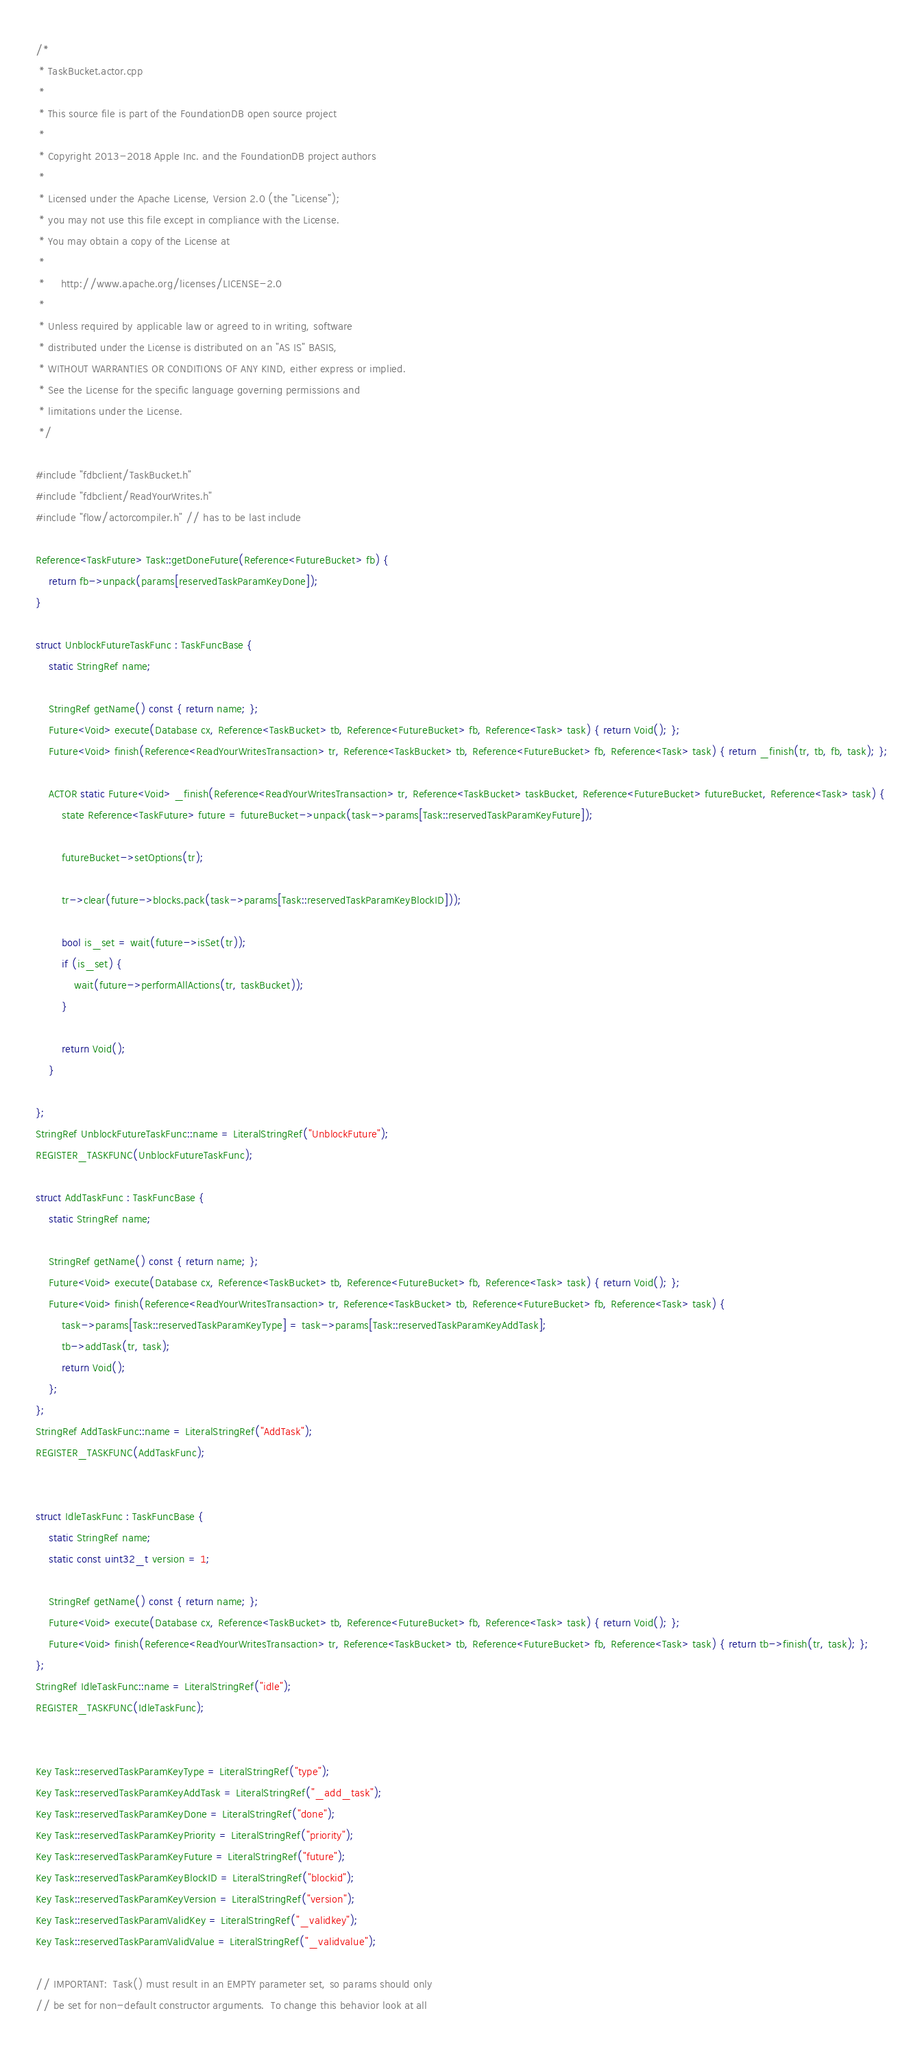<code> <loc_0><loc_0><loc_500><loc_500><_C++_>/*
 * TaskBucket.actor.cpp
 *
 * This source file is part of the FoundationDB open source project
 *
 * Copyright 2013-2018 Apple Inc. and the FoundationDB project authors
 *
 * Licensed under the Apache License, Version 2.0 (the "License");
 * you may not use this file except in compliance with the License.
 * You may obtain a copy of the License at
 *
 *     http://www.apache.org/licenses/LICENSE-2.0
 *
 * Unless required by applicable law or agreed to in writing, software
 * distributed under the License is distributed on an "AS IS" BASIS,
 * WITHOUT WARRANTIES OR CONDITIONS OF ANY KIND, either express or implied.
 * See the License for the specific language governing permissions and
 * limitations under the License.
 */

#include "fdbclient/TaskBucket.h"
#include "fdbclient/ReadYourWrites.h"
#include "flow/actorcompiler.h" // has to be last include

Reference<TaskFuture> Task::getDoneFuture(Reference<FutureBucket> fb) {
	return fb->unpack(params[reservedTaskParamKeyDone]);
}

struct UnblockFutureTaskFunc : TaskFuncBase {
	static StringRef name;

	StringRef getName() const { return name; };
	Future<Void> execute(Database cx, Reference<TaskBucket> tb, Reference<FutureBucket> fb, Reference<Task> task) { return Void(); };
	Future<Void> finish(Reference<ReadYourWritesTransaction> tr, Reference<TaskBucket> tb, Reference<FutureBucket> fb, Reference<Task> task) { return _finish(tr, tb, fb, task); };

	ACTOR static Future<Void> _finish(Reference<ReadYourWritesTransaction> tr, Reference<TaskBucket> taskBucket, Reference<FutureBucket> futureBucket, Reference<Task> task) {
		state Reference<TaskFuture> future = futureBucket->unpack(task->params[Task::reservedTaskParamKeyFuture]);

		futureBucket->setOptions(tr);

		tr->clear(future->blocks.pack(task->params[Task::reservedTaskParamKeyBlockID]));

		bool is_set = wait(future->isSet(tr));
		if (is_set) {
			wait(future->performAllActions(tr, taskBucket));
		}

		return Void();
	}

};
StringRef UnblockFutureTaskFunc::name = LiteralStringRef("UnblockFuture");
REGISTER_TASKFUNC(UnblockFutureTaskFunc);

struct AddTaskFunc : TaskFuncBase {
	static StringRef name;

	StringRef getName() const { return name; };
	Future<Void> execute(Database cx, Reference<TaskBucket> tb, Reference<FutureBucket> fb, Reference<Task> task) { return Void(); };
	Future<Void> finish(Reference<ReadYourWritesTransaction> tr, Reference<TaskBucket> tb, Reference<FutureBucket> fb, Reference<Task> task) { 
		task->params[Task::reservedTaskParamKeyType] = task->params[Task::reservedTaskParamKeyAddTask];
		tb->addTask(tr, task);
		return Void();
	};
};
StringRef AddTaskFunc::name = LiteralStringRef("AddTask");
REGISTER_TASKFUNC(AddTaskFunc);


struct IdleTaskFunc : TaskFuncBase {
	static StringRef name;
	static const uint32_t version = 1;

	StringRef getName() const { return name; };
	Future<Void> execute(Database cx, Reference<TaskBucket> tb, Reference<FutureBucket> fb, Reference<Task> task) { return Void(); };
	Future<Void> finish(Reference<ReadYourWritesTransaction> tr, Reference<TaskBucket> tb, Reference<FutureBucket> fb, Reference<Task> task) { return tb->finish(tr, task); };
};
StringRef IdleTaskFunc::name = LiteralStringRef("idle");
REGISTER_TASKFUNC(IdleTaskFunc);


Key Task::reservedTaskParamKeyType = LiteralStringRef("type");
Key Task::reservedTaskParamKeyAddTask = LiteralStringRef("_add_task");
Key Task::reservedTaskParamKeyDone = LiteralStringRef("done");
Key Task::reservedTaskParamKeyPriority = LiteralStringRef("priority");
Key Task::reservedTaskParamKeyFuture = LiteralStringRef("future");
Key Task::reservedTaskParamKeyBlockID = LiteralStringRef("blockid");
Key Task::reservedTaskParamKeyVersion = LiteralStringRef("version");
Key Task::reservedTaskParamValidKey = LiteralStringRef("_validkey");
Key Task::reservedTaskParamValidValue = LiteralStringRef("_validvalue");

// IMPORTANT:  Task() must result in an EMPTY parameter set, so params should only
// be set for non-default constructor arguments.  To change this behavior look at all</code> 